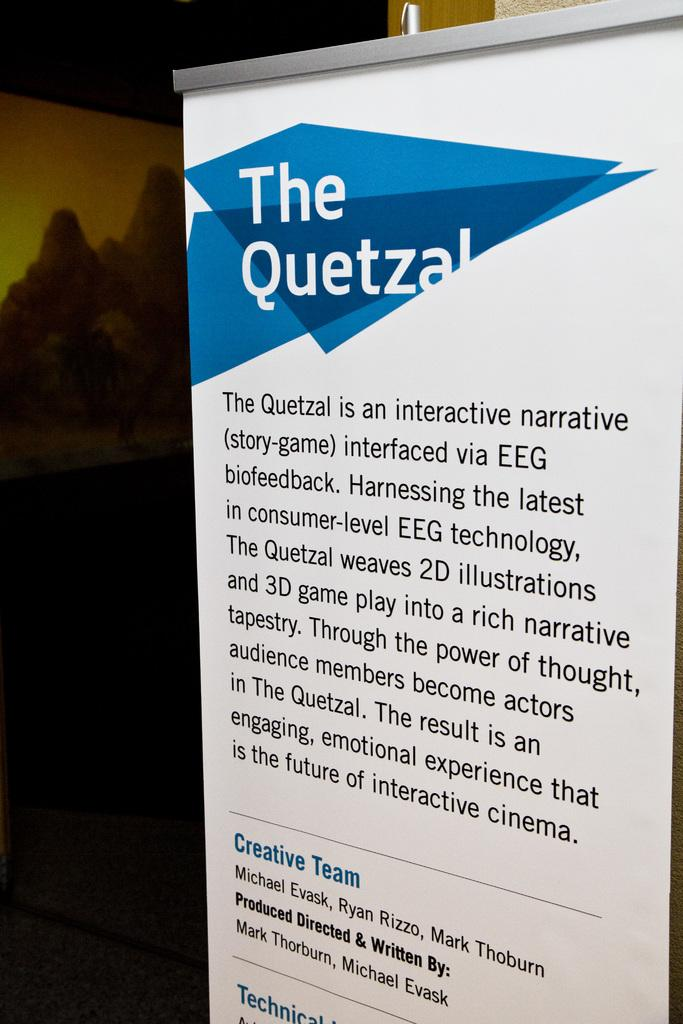<image>
Give a short and clear explanation of the subsequent image. A banner describes the Quetzal story-game that features 3D game play. 